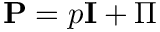<formula> <loc_0><loc_0><loc_500><loc_500>\mathbf P = p \mathbf I + \boldsymbol \Pi</formula> 